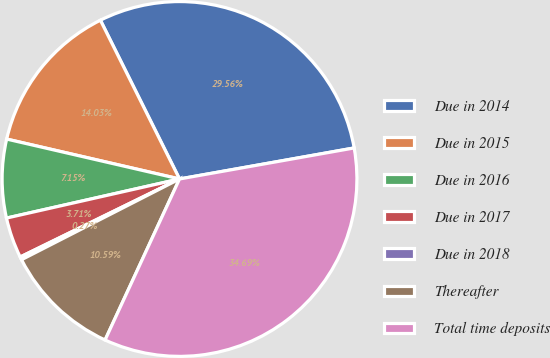Convert chart. <chart><loc_0><loc_0><loc_500><loc_500><pie_chart><fcel>Due in 2014<fcel>Due in 2015<fcel>Due in 2016<fcel>Due in 2017<fcel>Due in 2018<fcel>Thereafter<fcel>Total time deposits<nl><fcel>29.56%<fcel>14.03%<fcel>7.15%<fcel>3.71%<fcel>0.27%<fcel>10.59%<fcel>34.69%<nl></chart> 